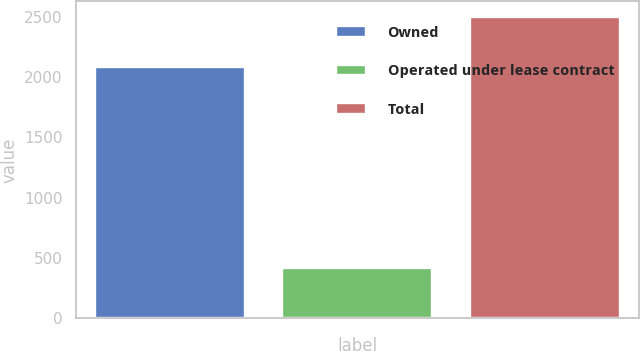Convert chart. <chart><loc_0><loc_0><loc_500><loc_500><bar_chart><fcel>Owned<fcel>Operated under lease contract<fcel>Total<nl><fcel>2084<fcel>417<fcel>2501<nl></chart> 